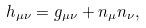<formula> <loc_0><loc_0><loc_500><loc_500>h _ { \mu \nu } = g _ { \mu \nu } + n _ { \mu } n _ { \nu } ,</formula> 